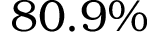<formula> <loc_0><loc_0><loc_500><loc_500>8 0 . 9 \%</formula> 